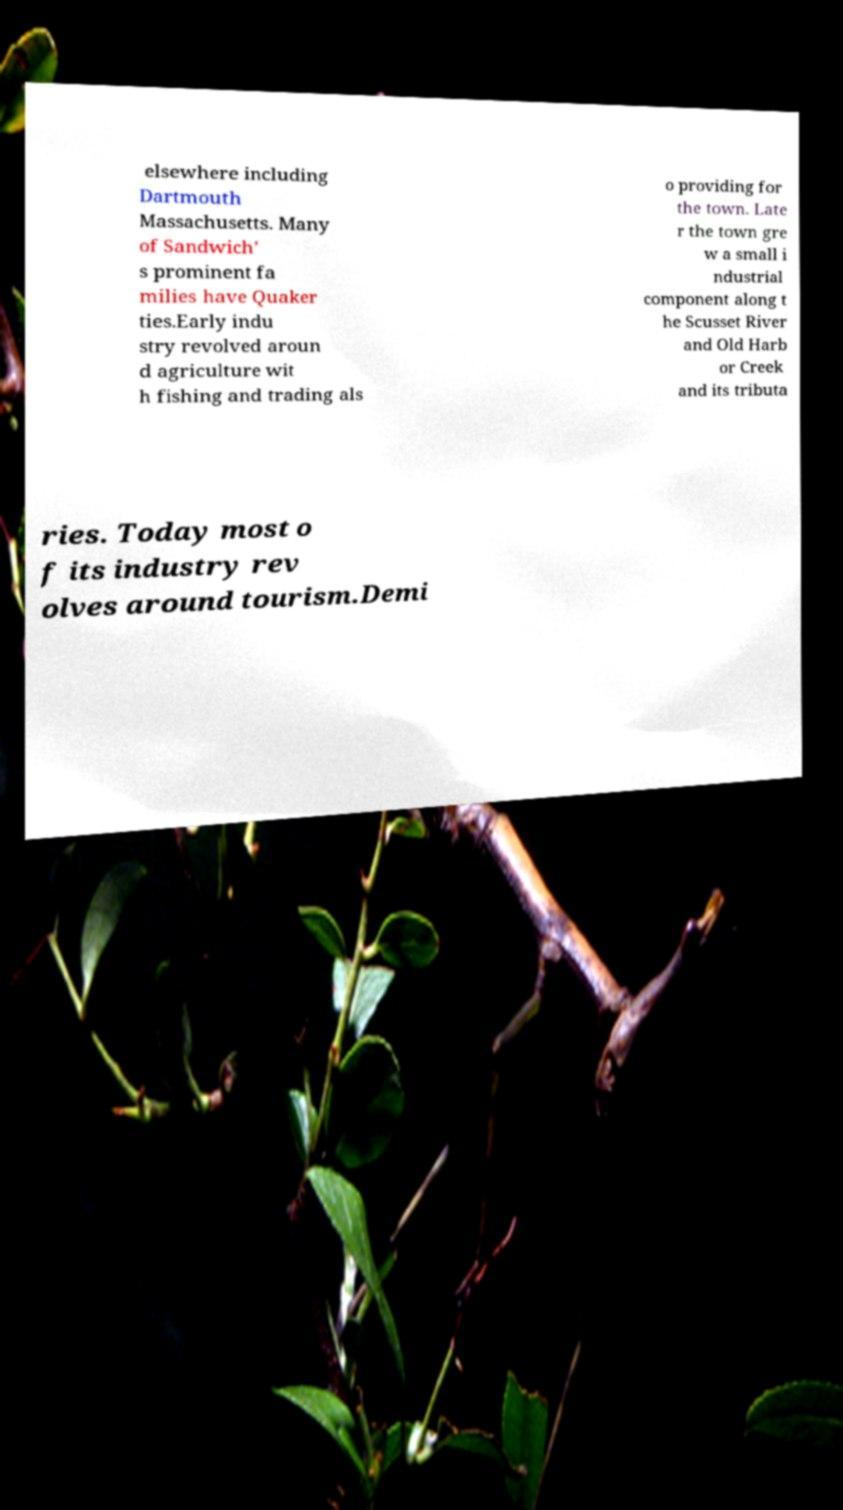Can you accurately transcribe the text from the provided image for me? elsewhere including Dartmouth Massachusetts. Many of Sandwich' s prominent fa milies have Quaker ties.Early indu stry revolved aroun d agriculture wit h fishing and trading als o providing for the town. Late r the town gre w a small i ndustrial component along t he Scusset River and Old Harb or Creek and its tributa ries. Today most o f its industry rev olves around tourism.Demi 